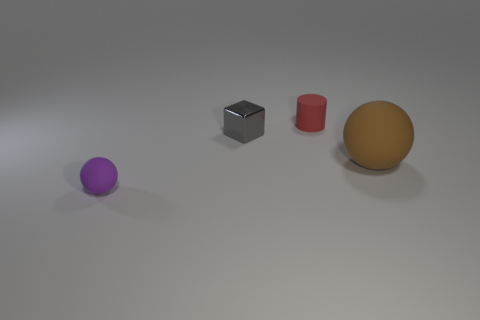Is there any other thing that is the same size as the brown sphere?
Your answer should be compact. No. Is the size of the gray object the same as the object that is on the right side of the tiny red cylinder?
Your answer should be very brief. No. What number of rubber objects are large balls or purple things?
Provide a short and direct response. 2. Are there more small blue balls than cylinders?
Make the answer very short. No. What shape is the small matte thing that is behind the matte thing that is in front of the brown rubber thing?
Ensure brevity in your answer.  Cylinder. There is a ball that is on the right side of the small rubber object to the right of the purple matte thing; is there a tiny thing behind it?
Offer a very short reply. Yes. The cylinder that is the same size as the cube is what color?
Your response must be concise. Red. There is a thing that is left of the brown ball and on the right side of the metal thing; what shape is it?
Offer a very short reply. Cylinder. What size is the ball that is right of the gray cube that is left of the brown matte ball?
Offer a very short reply. Large. What number of large objects are the same color as the small ball?
Provide a succinct answer. 0. 